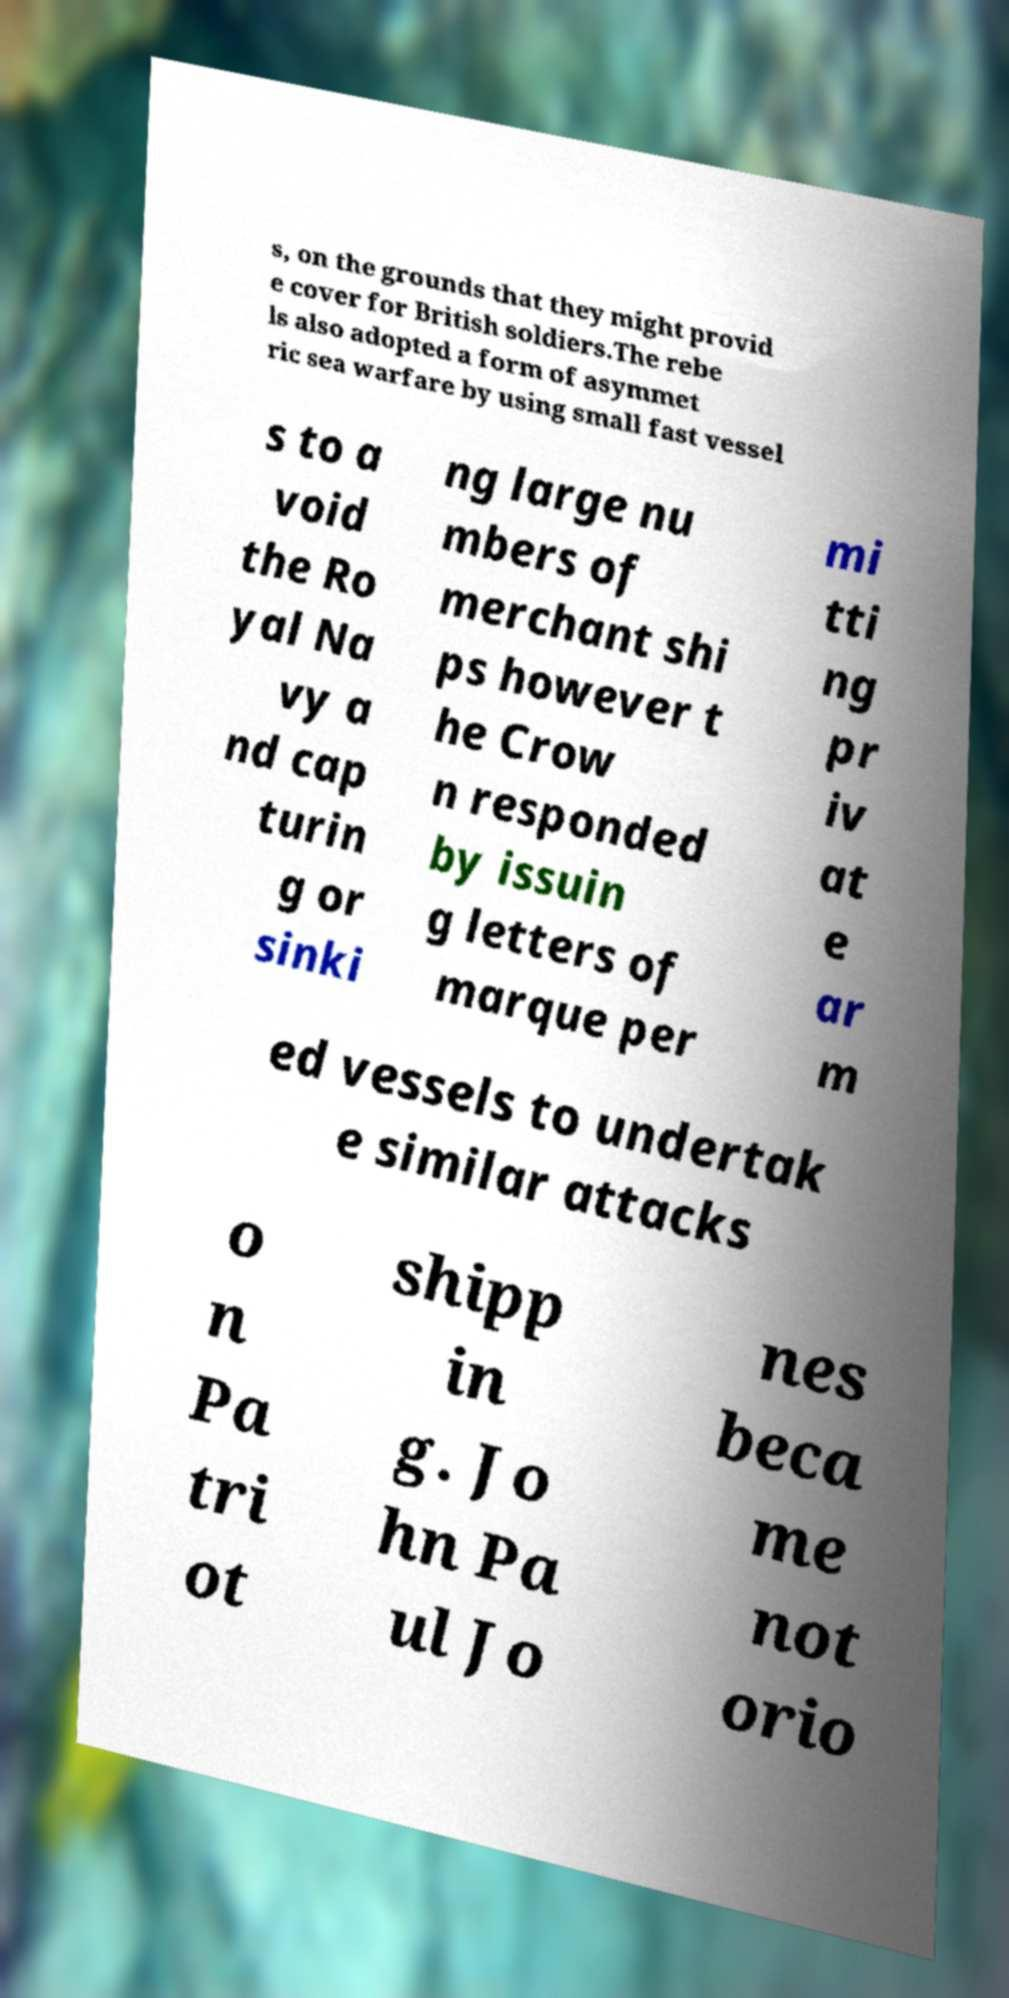Please read and relay the text visible in this image. What does it say? s, on the grounds that they might provid e cover for British soldiers.The rebe ls also adopted a form of asymmet ric sea warfare by using small fast vessel s to a void the Ro yal Na vy a nd cap turin g or sinki ng large nu mbers of merchant shi ps however t he Crow n responded by issuin g letters of marque per mi tti ng pr iv at e ar m ed vessels to undertak e similar attacks o n Pa tri ot shipp in g. Jo hn Pa ul Jo nes beca me not orio 